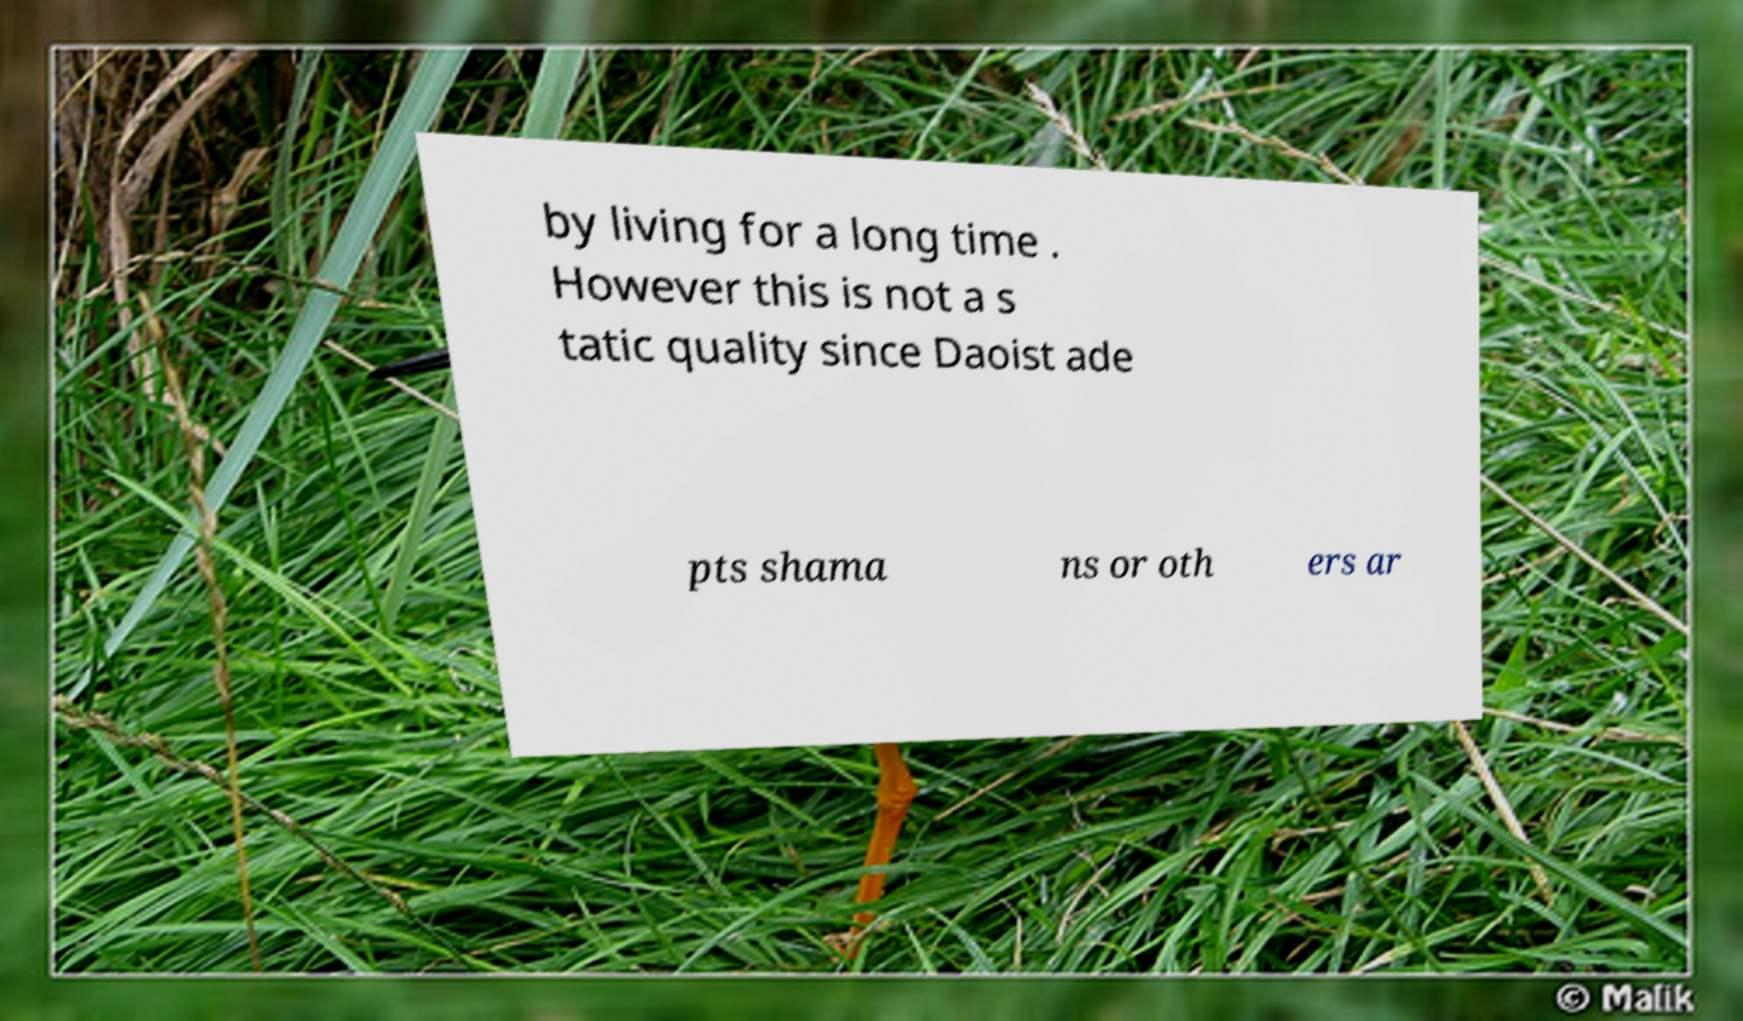Can you accurately transcribe the text from the provided image for me? by living for a long time . However this is not a s tatic quality since Daoist ade pts shama ns or oth ers ar 